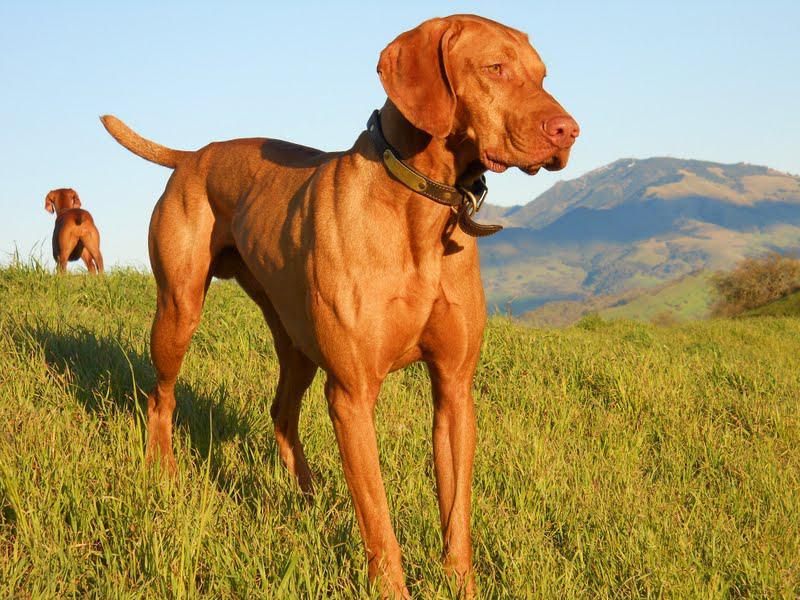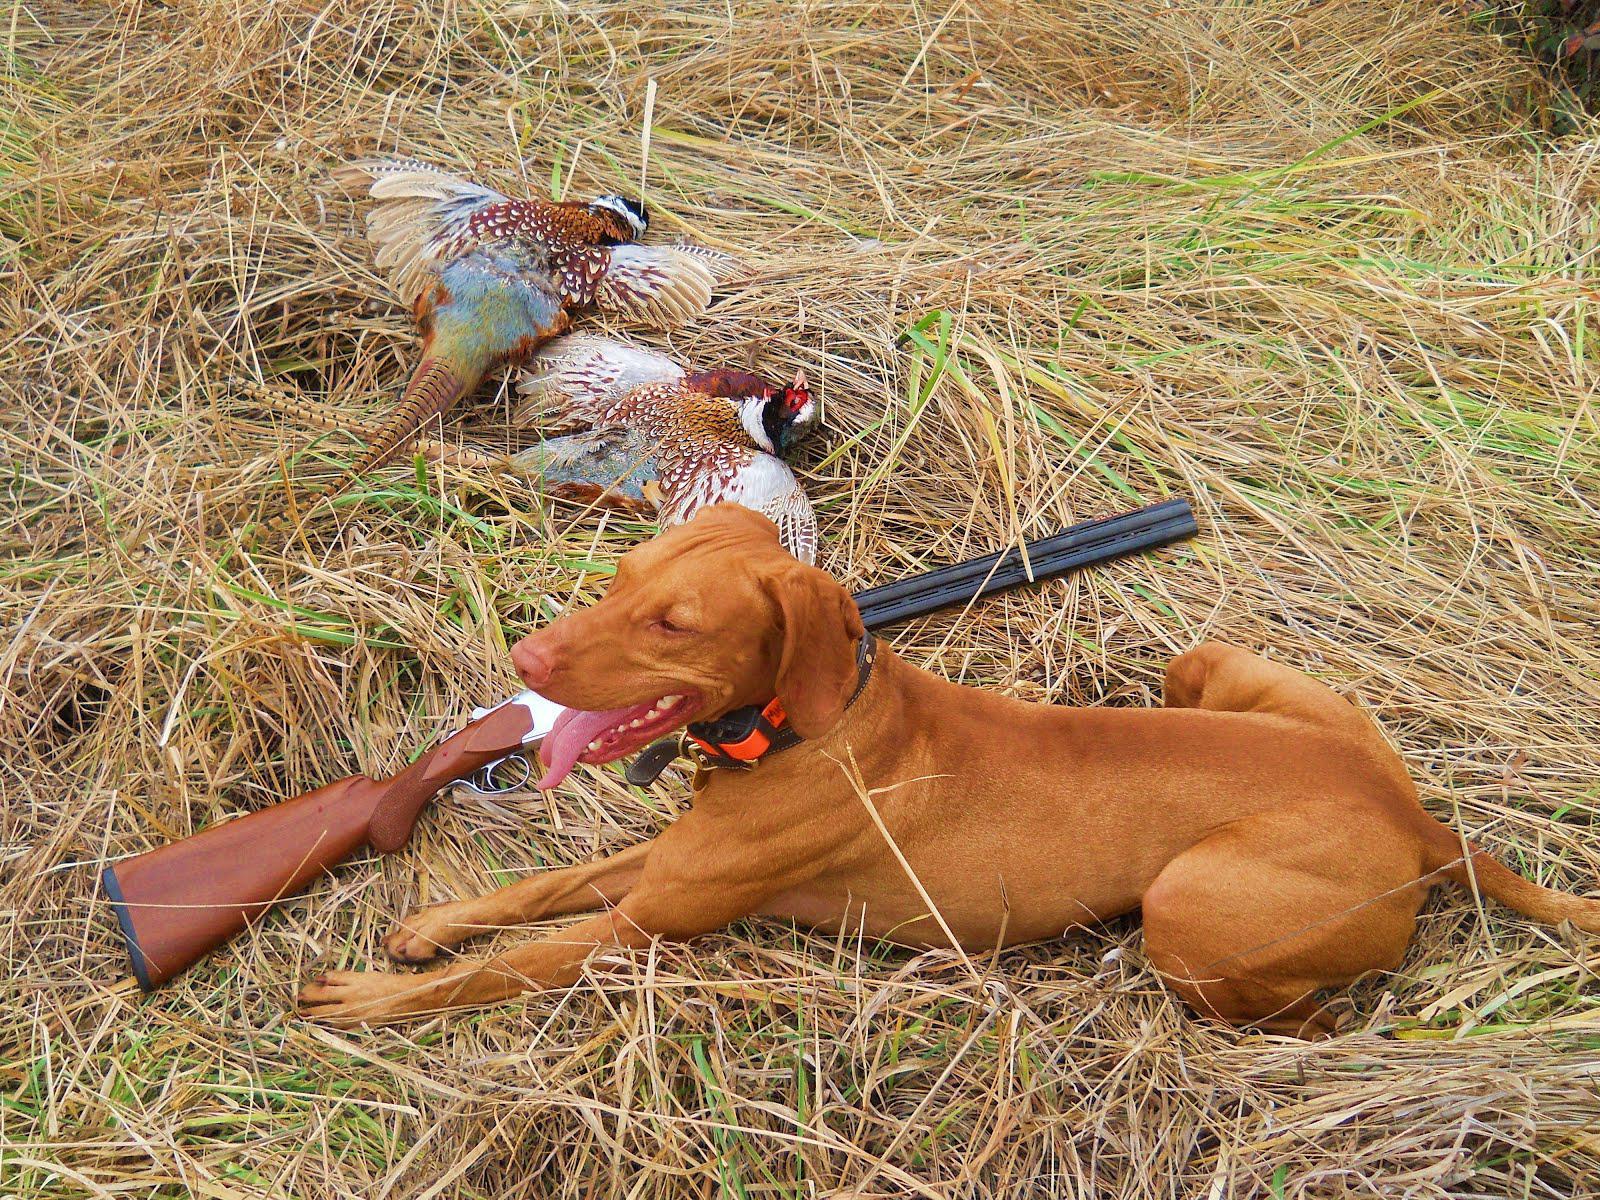The first image is the image on the left, the second image is the image on the right. For the images shown, is this caption "The dog on the right is posed with a hunting weapon and a fowl, while the dog on the left has a very visible collar." true? Answer yes or no. Yes. The first image is the image on the left, the second image is the image on the right. Examine the images to the left and right. Is the description "A dog has at least one front paw off the ground." accurate? Answer yes or no. No. 